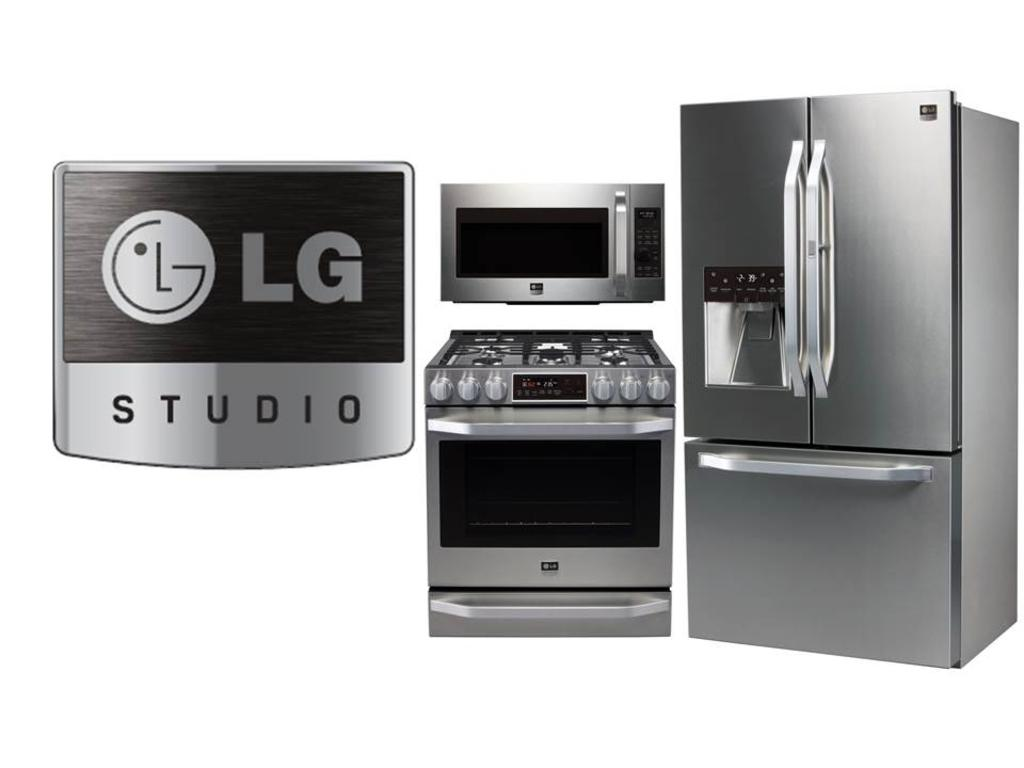Provide a one-sentence caption for the provided image. A stainless steel fridge, Stove, and Microwave from LG Studio. 